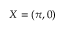<formula> <loc_0><loc_0><loc_500><loc_500>X = ( \pi , 0 )</formula> 